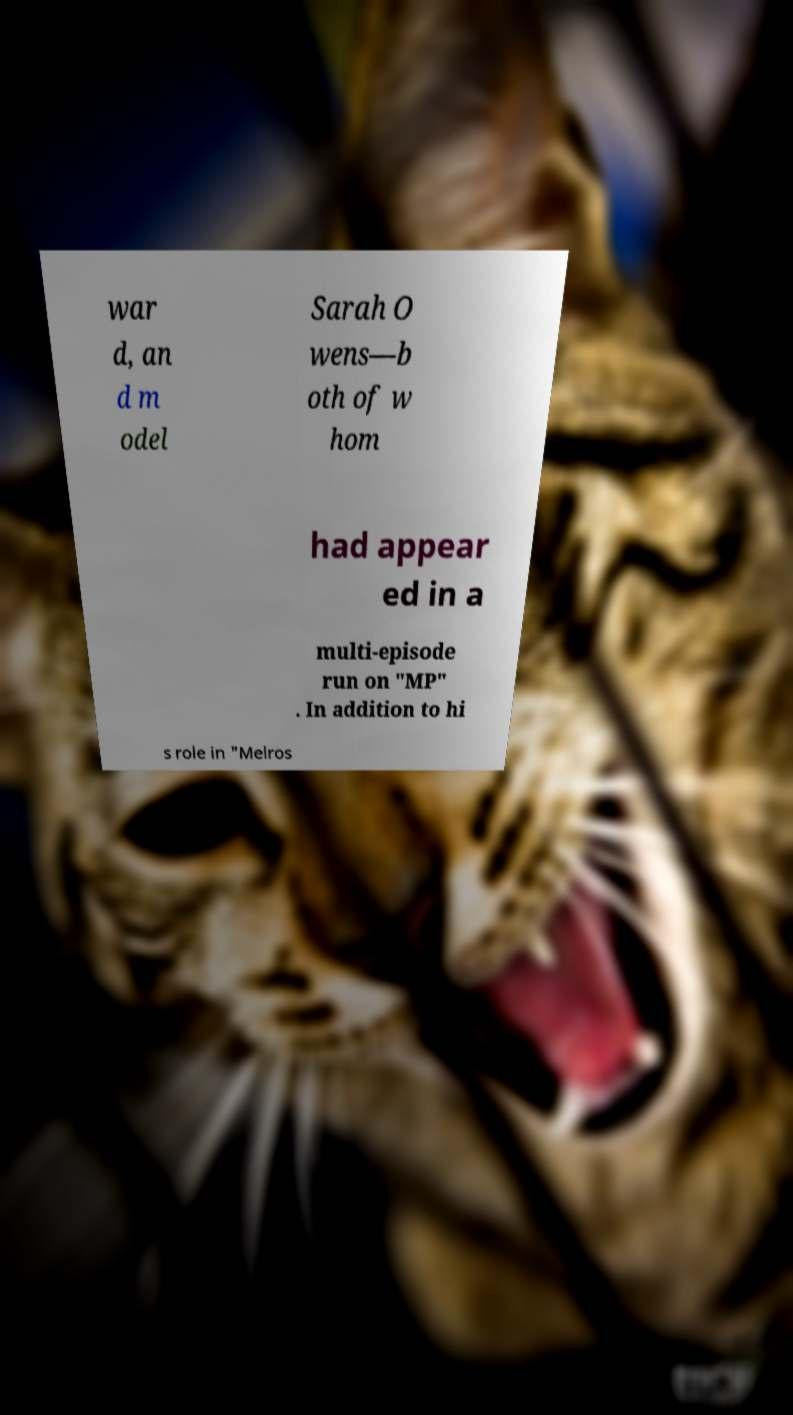Please identify and transcribe the text found in this image. war d, an d m odel Sarah O wens—b oth of w hom had appear ed in a multi-episode run on "MP" . In addition to hi s role in "Melros 